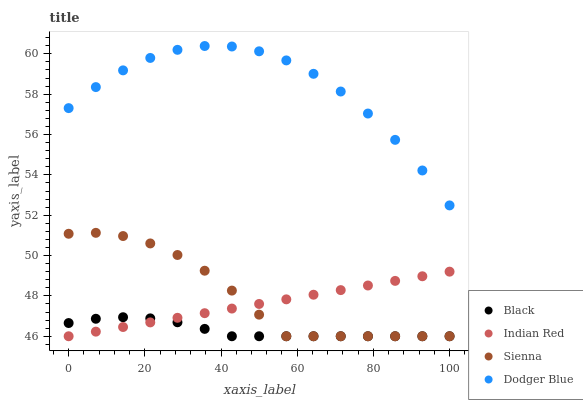Does Black have the minimum area under the curve?
Answer yes or no. Yes. Does Dodger Blue have the maximum area under the curve?
Answer yes or no. Yes. Does Dodger Blue have the minimum area under the curve?
Answer yes or no. No. Does Black have the maximum area under the curve?
Answer yes or no. No. Is Indian Red the smoothest?
Answer yes or no. Yes. Is Dodger Blue the roughest?
Answer yes or no. Yes. Is Black the smoothest?
Answer yes or no. No. Is Black the roughest?
Answer yes or no. No. Does Sienna have the lowest value?
Answer yes or no. Yes. Does Dodger Blue have the lowest value?
Answer yes or no. No. Does Dodger Blue have the highest value?
Answer yes or no. Yes. Does Black have the highest value?
Answer yes or no. No. Is Black less than Dodger Blue?
Answer yes or no. Yes. Is Dodger Blue greater than Sienna?
Answer yes or no. Yes. Does Black intersect Indian Red?
Answer yes or no. Yes. Is Black less than Indian Red?
Answer yes or no. No. Is Black greater than Indian Red?
Answer yes or no. No. Does Black intersect Dodger Blue?
Answer yes or no. No. 